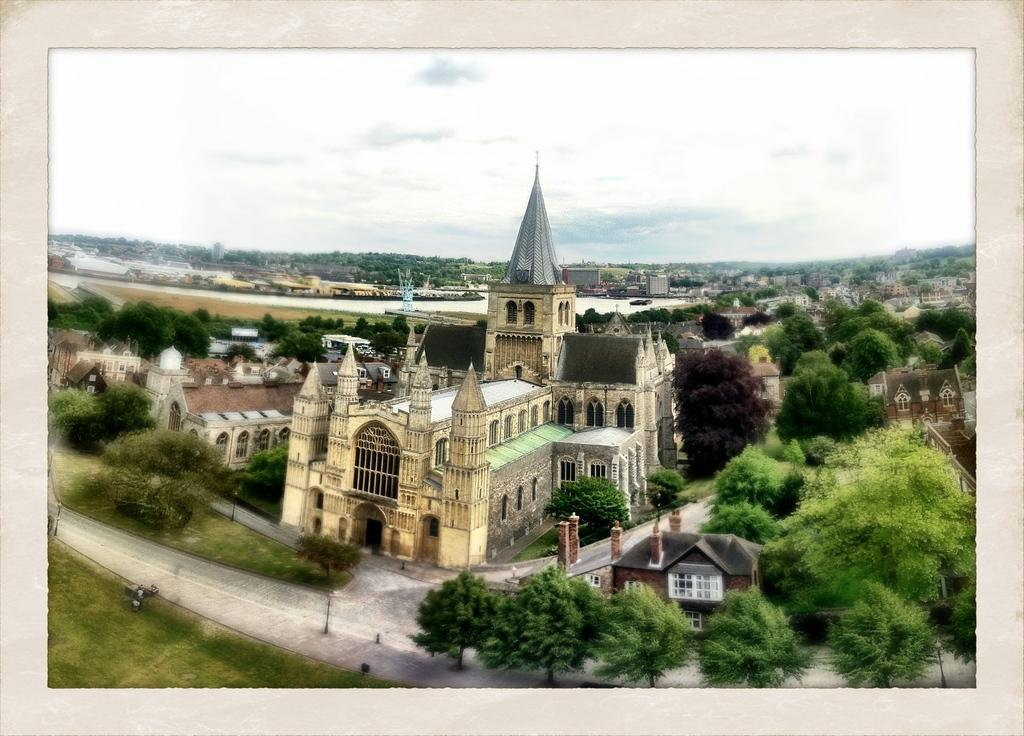What type of view is shown in the image? The image is an aerial view of a city. What structures can be seen in the image? There are buildings in the image. What type of vegetation is present in the image? There are trees in the image. What is visible at the top of the image? The sky is visible at the top of the image. Where is the clock located in the image? There is no clock present in the image. What type of soda can be seen being poured in the image? There is no soda present in the image. 